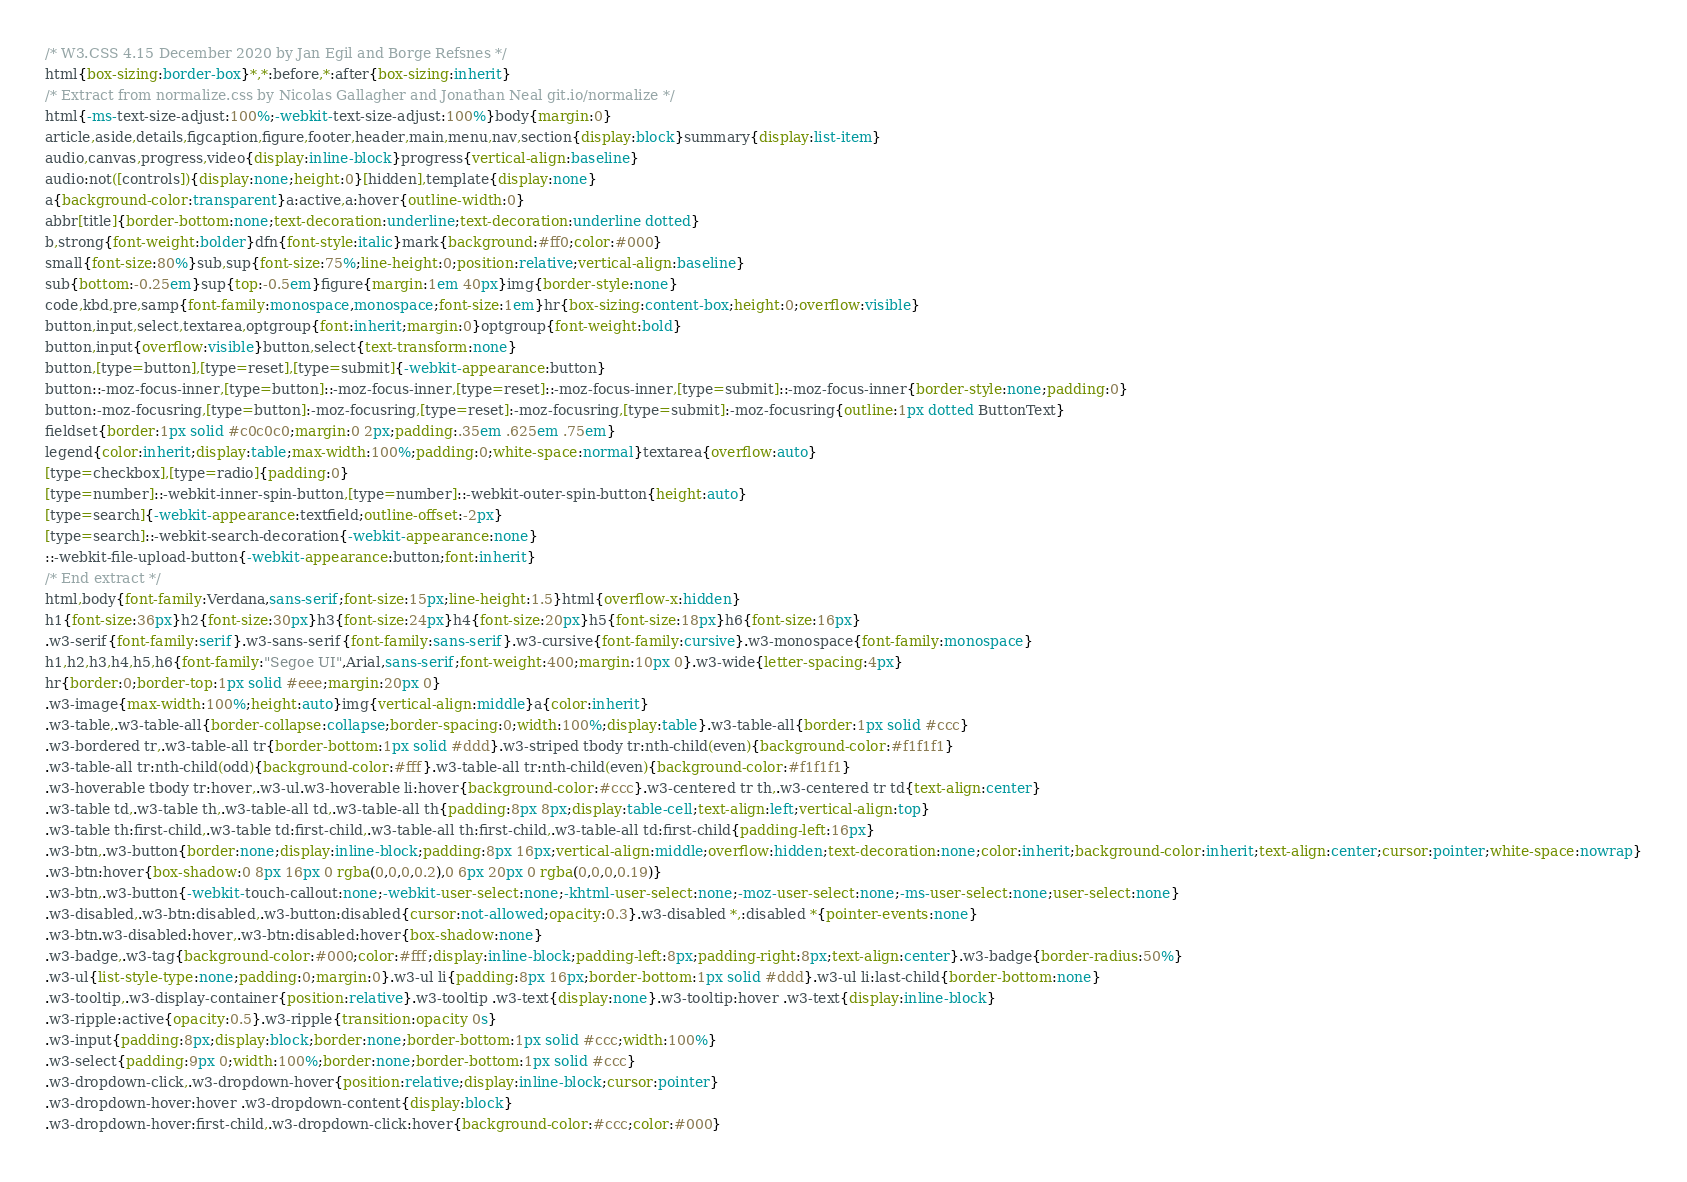Convert code to text. <code><loc_0><loc_0><loc_500><loc_500><_CSS_>/* W3.CSS 4.15 December 2020 by Jan Egil and Borge Refsnes */
html{box-sizing:border-box}*,*:before,*:after{box-sizing:inherit}
/* Extract from normalize.css by Nicolas Gallagher and Jonathan Neal git.io/normalize */
html{-ms-text-size-adjust:100%;-webkit-text-size-adjust:100%}body{margin:0}
article,aside,details,figcaption,figure,footer,header,main,menu,nav,section{display:block}summary{display:list-item}
audio,canvas,progress,video{display:inline-block}progress{vertical-align:baseline}
audio:not([controls]){display:none;height:0}[hidden],template{display:none}
a{background-color:transparent}a:active,a:hover{outline-width:0}
abbr[title]{border-bottom:none;text-decoration:underline;text-decoration:underline dotted}
b,strong{font-weight:bolder}dfn{font-style:italic}mark{background:#ff0;color:#000}
small{font-size:80%}sub,sup{font-size:75%;line-height:0;position:relative;vertical-align:baseline}
sub{bottom:-0.25em}sup{top:-0.5em}figure{margin:1em 40px}img{border-style:none}
code,kbd,pre,samp{font-family:monospace,monospace;font-size:1em}hr{box-sizing:content-box;height:0;overflow:visible}
button,input,select,textarea,optgroup{font:inherit;margin:0}optgroup{font-weight:bold}
button,input{overflow:visible}button,select{text-transform:none}
button,[type=button],[type=reset],[type=submit]{-webkit-appearance:button}
button::-moz-focus-inner,[type=button]::-moz-focus-inner,[type=reset]::-moz-focus-inner,[type=submit]::-moz-focus-inner{border-style:none;padding:0}
button:-moz-focusring,[type=button]:-moz-focusring,[type=reset]:-moz-focusring,[type=submit]:-moz-focusring{outline:1px dotted ButtonText}
fieldset{border:1px solid #c0c0c0;margin:0 2px;padding:.35em .625em .75em}
legend{color:inherit;display:table;max-width:100%;padding:0;white-space:normal}textarea{overflow:auto}
[type=checkbox],[type=radio]{padding:0}
[type=number]::-webkit-inner-spin-button,[type=number]::-webkit-outer-spin-button{height:auto}
[type=search]{-webkit-appearance:textfield;outline-offset:-2px}
[type=search]::-webkit-search-decoration{-webkit-appearance:none}
::-webkit-file-upload-button{-webkit-appearance:button;font:inherit}
/* End extract */
html,body{font-family:Verdana,sans-serif;font-size:15px;line-height:1.5}html{overflow-x:hidden}
h1{font-size:36px}h2{font-size:30px}h3{font-size:24px}h4{font-size:20px}h5{font-size:18px}h6{font-size:16px}
.w3-serif{font-family:serif}.w3-sans-serif{font-family:sans-serif}.w3-cursive{font-family:cursive}.w3-monospace{font-family:monospace}
h1,h2,h3,h4,h5,h6{font-family:"Segoe UI",Arial,sans-serif;font-weight:400;margin:10px 0}.w3-wide{letter-spacing:4px}
hr{border:0;border-top:1px solid #eee;margin:20px 0}
.w3-image{max-width:100%;height:auto}img{vertical-align:middle}a{color:inherit}
.w3-table,.w3-table-all{border-collapse:collapse;border-spacing:0;width:100%;display:table}.w3-table-all{border:1px solid #ccc}
.w3-bordered tr,.w3-table-all tr{border-bottom:1px solid #ddd}.w3-striped tbody tr:nth-child(even){background-color:#f1f1f1}
.w3-table-all tr:nth-child(odd){background-color:#fff}.w3-table-all tr:nth-child(even){background-color:#f1f1f1}
.w3-hoverable tbody tr:hover,.w3-ul.w3-hoverable li:hover{background-color:#ccc}.w3-centered tr th,.w3-centered tr td{text-align:center}
.w3-table td,.w3-table th,.w3-table-all td,.w3-table-all th{padding:8px 8px;display:table-cell;text-align:left;vertical-align:top}
.w3-table th:first-child,.w3-table td:first-child,.w3-table-all th:first-child,.w3-table-all td:first-child{padding-left:16px}
.w3-btn,.w3-button{border:none;display:inline-block;padding:8px 16px;vertical-align:middle;overflow:hidden;text-decoration:none;color:inherit;background-color:inherit;text-align:center;cursor:pointer;white-space:nowrap}
.w3-btn:hover{box-shadow:0 8px 16px 0 rgba(0,0,0,0.2),0 6px 20px 0 rgba(0,0,0,0.19)}
.w3-btn,.w3-button{-webkit-touch-callout:none;-webkit-user-select:none;-khtml-user-select:none;-moz-user-select:none;-ms-user-select:none;user-select:none}   
.w3-disabled,.w3-btn:disabled,.w3-button:disabled{cursor:not-allowed;opacity:0.3}.w3-disabled *,:disabled *{pointer-events:none}
.w3-btn.w3-disabled:hover,.w3-btn:disabled:hover{box-shadow:none}
.w3-badge,.w3-tag{background-color:#000;color:#fff;display:inline-block;padding-left:8px;padding-right:8px;text-align:center}.w3-badge{border-radius:50%}
.w3-ul{list-style-type:none;padding:0;margin:0}.w3-ul li{padding:8px 16px;border-bottom:1px solid #ddd}.w3-ul li:last-child{border-bottom:none}
.w3-tooltip,.w3-display-container{position:relative}.w3-tooltip .w3-text{display:none}.w3-tooltip:hover .w3-text{display:inline-block}
.w3-ripple:active{opacity:0.5}.w3-ripple{transition:opacity 0s}
.w3-input{padding:8px;display:block;border:none;border-bottom:1px solid #ccc;width:100%}
.w3-select{padding:9px 0;width:100%;border:none;border-bottom:1px solid #ccc}
.w3-dropdown-click,.w3-dropdown-hover{position:relative;display:inline-block;cursor:pointer}
.w3-dropdown-hover:hover .w3-dropdown-content{display:block}
.w3-dropdown-hover:first-child,.w3-dropdown-click:hover{background-color:#ccc;color:#000}</code> 